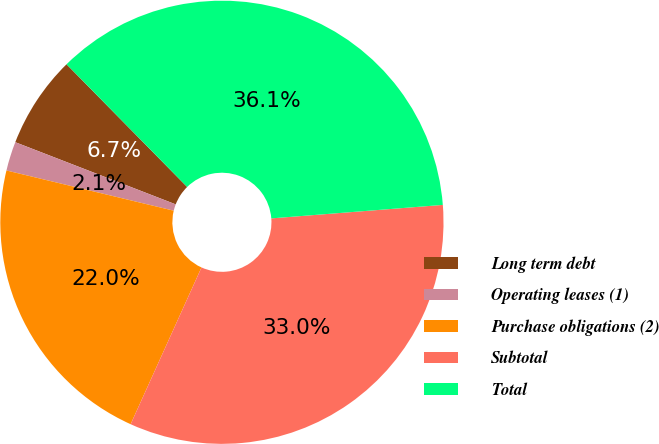Convert chart. <chart><loc_0><loc_0><loc_500><loc_500><pie_chart><fcel>Long term debt<fcel>Operating leases (1)<fcel>Purchase obligations (2)<fcel>Subtotal<fcel>Total<nl><fcel>6.75%<fcel>2.13%<fcel>22.0%<fcel>33.01%<fcel>36.12%<nl></chart> 